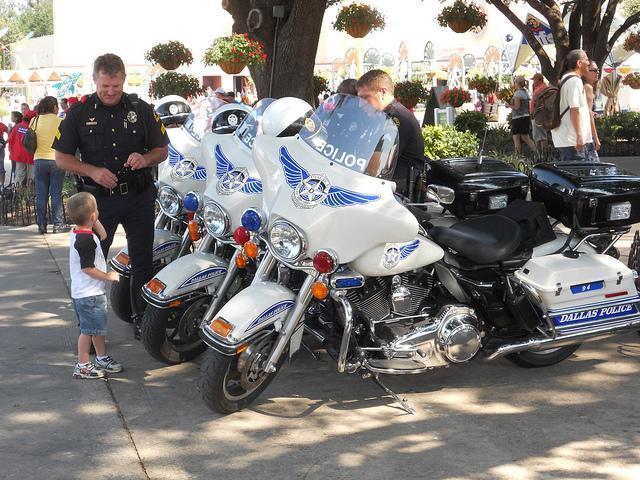What NFL team plays in the town?
From the following four choices, select the correct answer to address the question.
Options: Chiefs, texans, patriots, cowboys. Cowboys. 